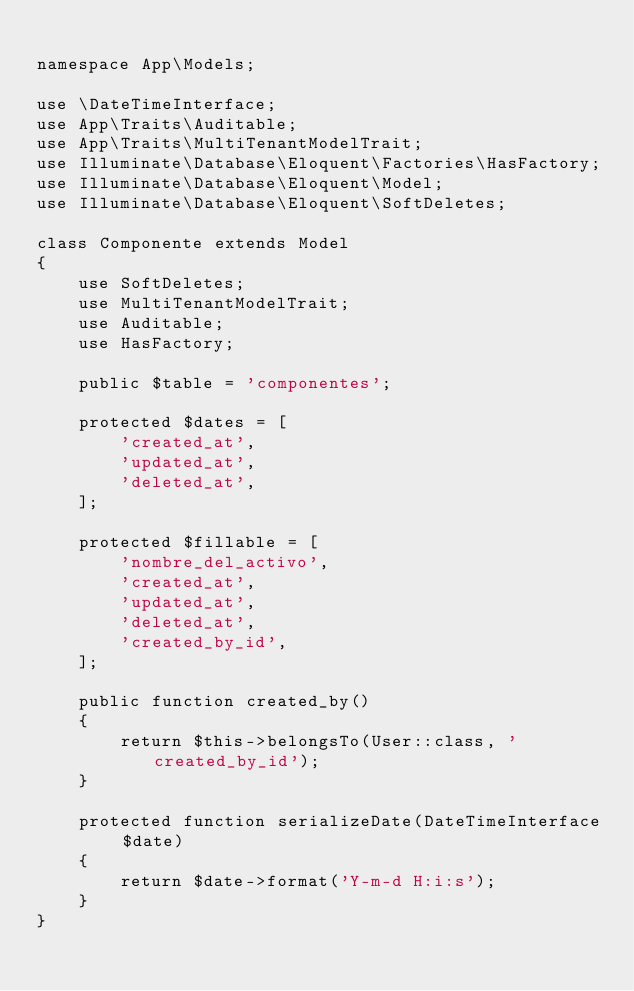Convert code to text. <code><loc_0><loc_0><loc_500><loc_500><_PHP_>
namespace App\Models;

use \DateTimeInterface;
use App\Traits\Auditable;
use App\Traits\MultiTenantModelTrait;
use Illuminate\Database\Eloquent\Factories\HasFactory;
use Illuminate\Database\Eloquent\Model;
use Illuminate\Database\Eloquent\SoftDeletes;

class Componente extends Model
{
    use SoftDeletes;
    use MultiTenantModelTrait;
    use Auditable;
    use HasFactory;

    public $table = 'componentes';

    protected $dates = [
        'created_at',
        'updated_at',
        'deleted_at',
    ];

    protected $fillable = [
        'nombre_del_activo',
        'created_at',
        'updated_at',
        'deleted_at',
        'created_by_id',
    ];

    public function created_by()
    {
        return $this->belongsTo(User::class, 'created_by_id');
    }

    protected function serializeDate(DateTimeInterface $date)
    {
        return $date->format('Y-m-d H:i:s');
    }
}
</code> 